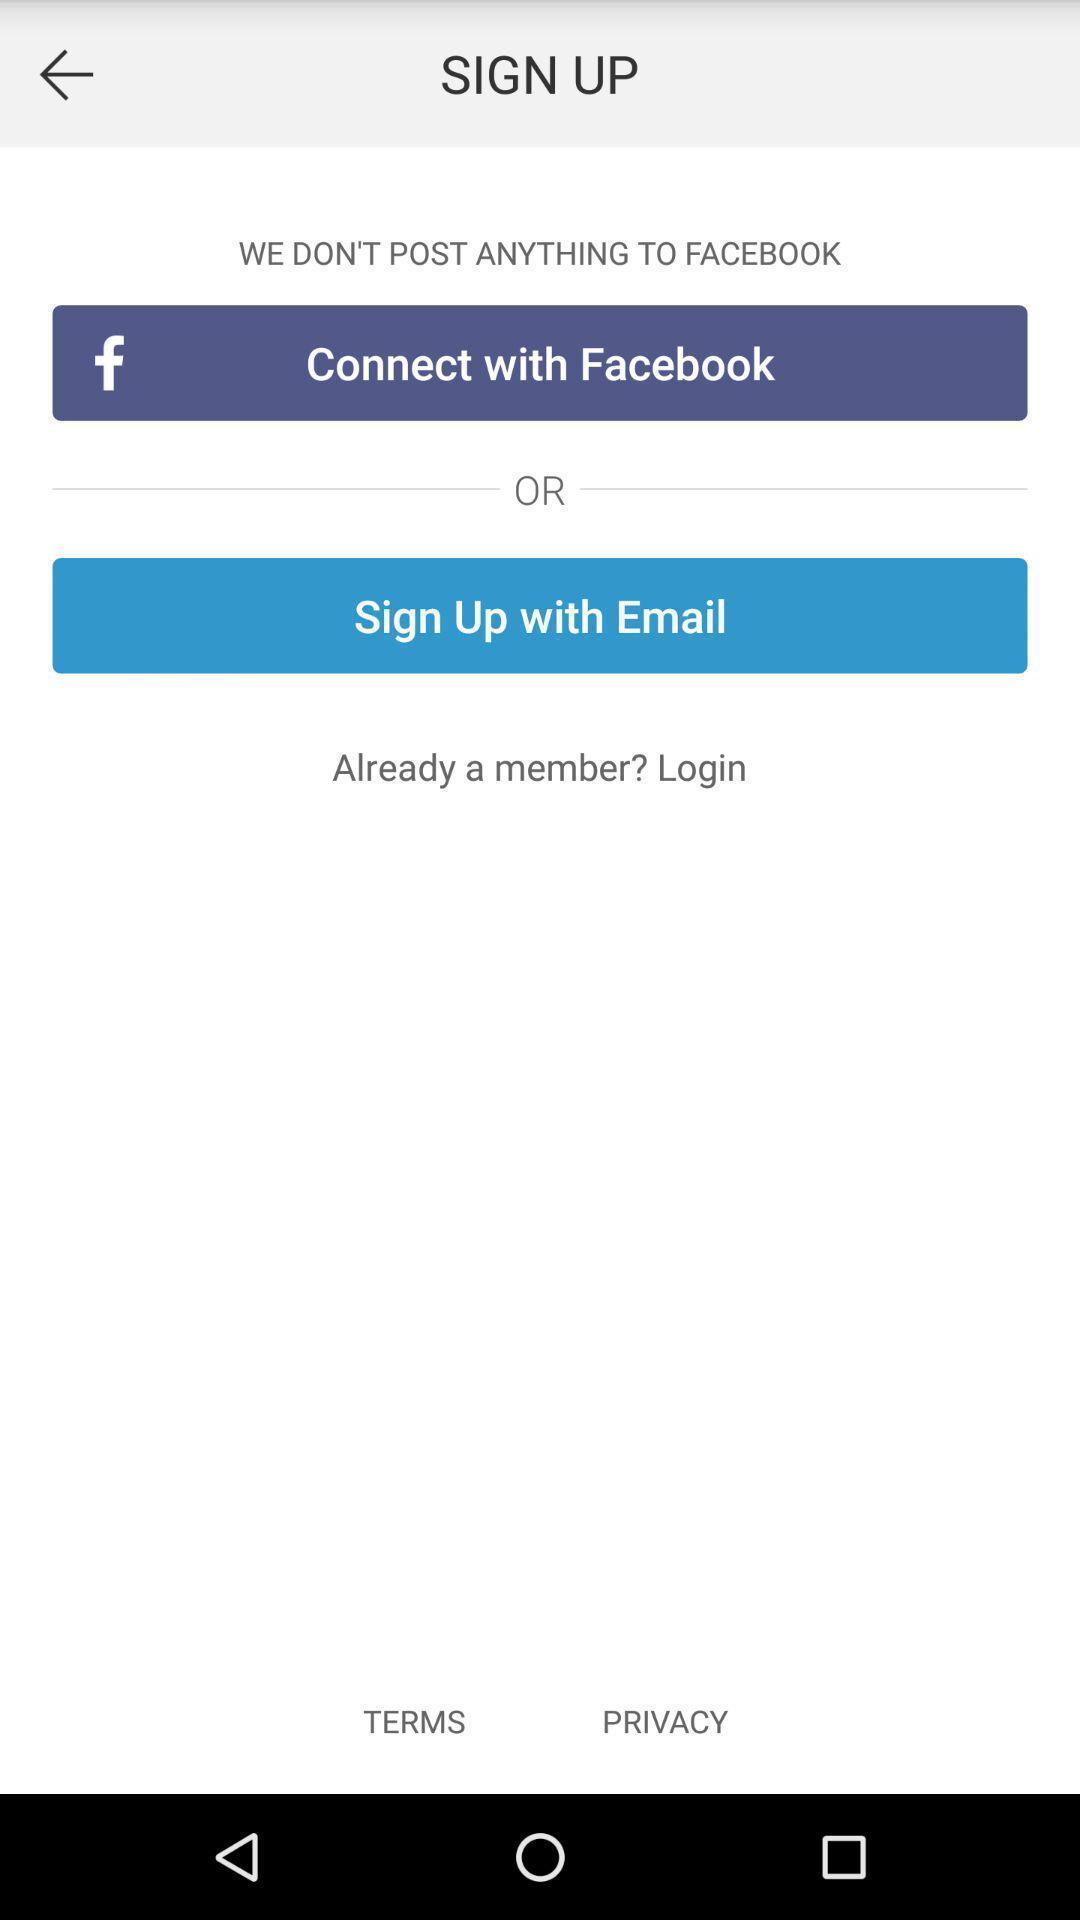Summarize the main components in this picture. Sign up page with social websites. 